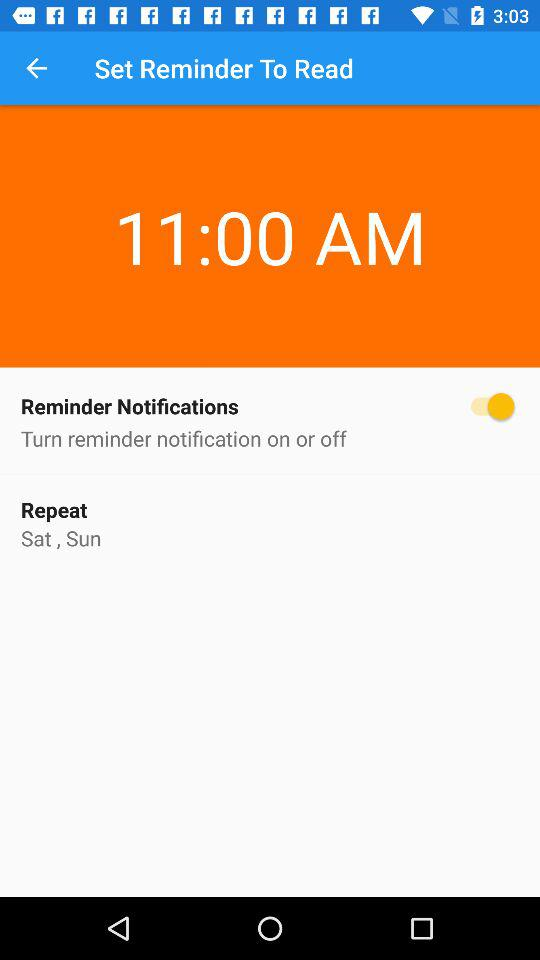What is the status of "Reminder Notifications"? The status is "on". 